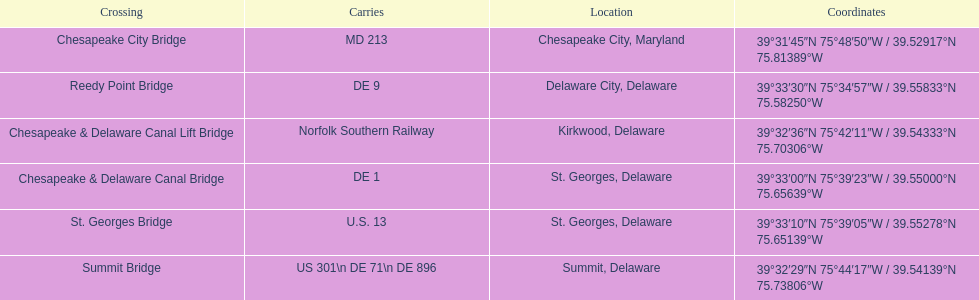Which bridge is in delaware and carries de 9? Reedy Point Bridge. 